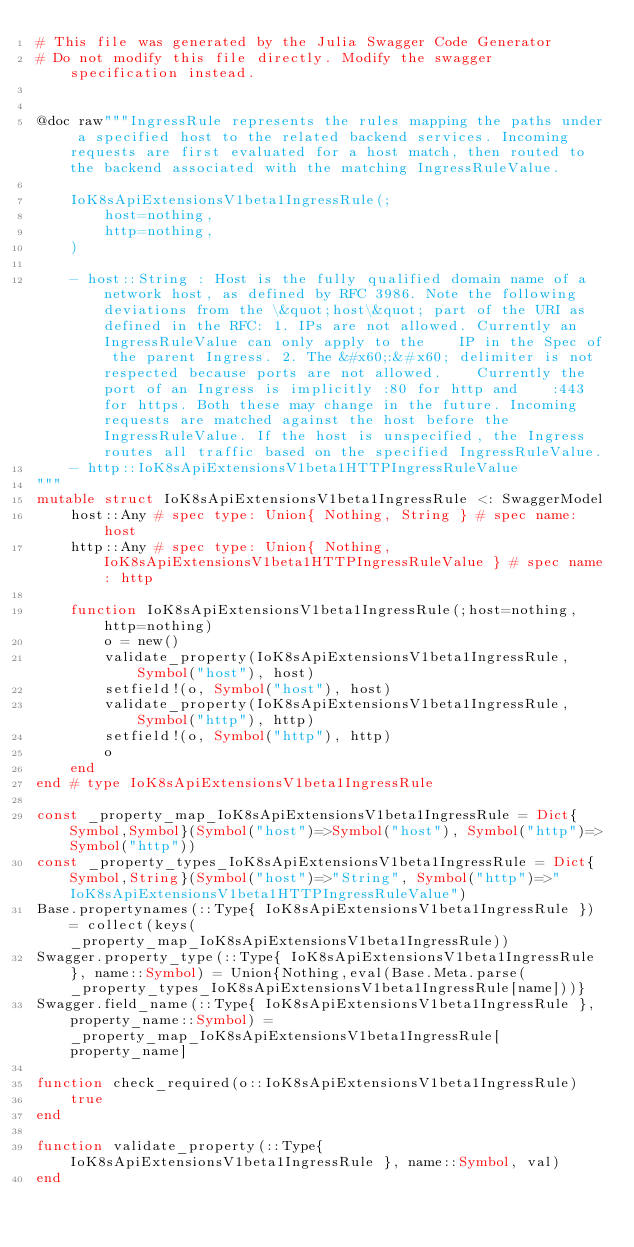Convert code to text. <code><loc_0><loc_0><loc_500><loc_500><_Julia_># This file was generated by the Julia Swagger Code Generator
# Do not modify this file directly. Modify the swagger specification instead.


@doc raw"""IngressRule represents the rules mapping the paths under a specified host to the related backend services. Incoming requests are first evaluated for a host match, then routed to the backend associated with the matching IngressRuleValue.

    IoK8sApiExtensionsV1beta1IngressRule(;
        host=nothing,
        http=nothing,
    )

    - host::String : Host is the fully qualified domain name of a network host, as defined by RFC 3986. Note the following deviations from the \&quot;host\&quot; part of the URI as defined in the RFC: 1. IPs are not allowed. Currently an IngressRuleValue can only apply to the    IP in the Spec of the parent Ingress. 2. The &#x60;:&#x60; delimiter is not respected because ports are not allowed.    Currently the port of an Ingress is implicitly :80 for http and    :443 for https. Both these may change in the future. Incoming requests are matched against the host before the IngressRuleValue. If the host is unspecified, the Ingress routes all traffic based on the specified IngressRuleValue.
    - http::IoK8sApiExtensionsV1beta1HTTPIngressRuleValue
"""
mutable struct IoK8sApiExtensionsV1beta1IngressRule <: SwaggerModel
    host::Any # spec type: Union{ Nothing, String } # spec name: host
    http::Any # spec type: Union{ Nothing, IoK8sApiExtensionsV1beta1HTTPIngressRuleValue } # spec name: http

    function IoK8sApiExtensionsV1beta1IngressRule(;host=nothing, http=nothing)
        o = new()
        validate_property(IoK8sApiExtensionsV1beta1IngressRule, Symbol("host"), host)
        setfield!(o, Symbol("host"), host)
        validate_property(IoK8sApiExtensionsV1beta1IngressRule, Symbol("http"), http)
        setfield!(o, Symbol("http"), http)
        o
    end
end # type IoK8sApiExtensionsV1beta1IngressRule

const _property_map_IoK8sApiExtensionsV1beta1IngressRule = Dict{Symbol,Symbol}(Symbol("host")=>Symbol("host"), Symbol("http")=>Symbol("http"))
const _property_types_IoK8sApiExtensionsV1beta1IngressRule = Dict{Symbol,String}(Symbol("host")=>"String", Symbol("http")=>"IoK8sApiExtensionsV1beta1HTTPIngressRuleValue")
Base.propertynames(::Type{ IoK8sApiExtensionsV1beta1IngressRule }) = collect(keys(_property_map_IoK8sApiExtensionsV1beta1IngressRule))
Swagger.property_type(::Type{ IoK8sApiExtensionsV1beta1IngressRule }, name::Symbol) = Union{Nothing,eval(Base.Meta.parse(_property_types_IoK8sApiExtensionsV1beta1IngressRule[name]))}
Swagger.field_name(::Type{ IoK8sApiExtensionsV1beta1IngressRule }, property_name::Symbol) =  _property_map_IoK8sApiExtensionsV1beta1IngressRule[property_name]

function check_required(o::IoK8sApiExtensionsV1beta1IngressRule)
    true
end

function validate_property(::Type{ IoK8sApiExtensionsV1beta1IngressRule }, name::Symbol, val)
end
</code> 